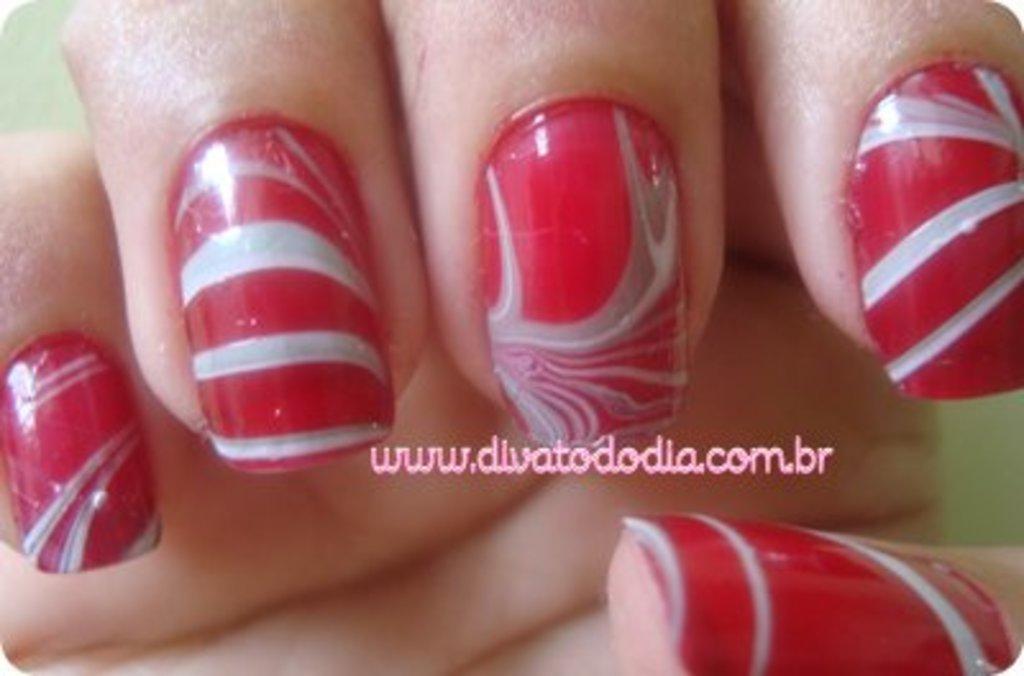Is that a .com or .br?
Ensure brevity in your answer.  .br. What is the website's name?
Make the answer very short. Www.divatododia.com.br. 